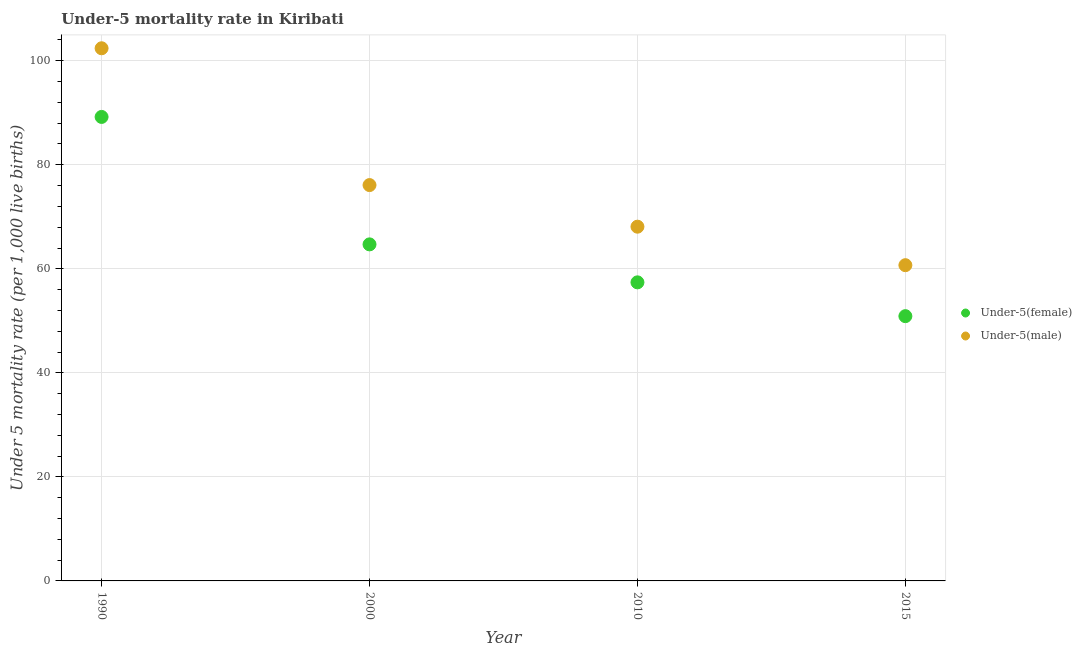What is the under-5 female mortality rate in 2010?
Make the answer very short. 57.4. Across all years, what is the maximum under-5 male mortality rate?
Keep it short and to the point. 102.4. Across all years, what is the minimum under-5 female mortality rate?
Provide a short and direct response. 50.9. In which year was the under-5 female mortality rate minimum?
Offer a very short reply. 2015. What is the total under-5 female mortality rate in the graph?
Provide a short and direct response. 262.2. What is the difference between the under-5 female mortality rate in 2000 and that in 2010?
Give a very brief answer. 7.3. What is the difference between the under-5 male mortality rate in 2010 and the under-5 female mortality rate in 2015?
Your answer should be very brief. 17.2. What is the average under-5 female mortality rate per year?
Ensure brevity in your answer.  65.55. In the year 2015, what is the difference between the under-5 female mortality rate and under-5 male mortality rate?
Your answer should be compact. -9.8. What is the ratio of the under-5 male mortality rate in 1990 to that in 2010?
Keep it short and to the point. 1.5. Is the under-5 female mortality rate in 2000 less than that in 2015?
Ensure brevity in your answer.  No. Is the difference between the under-5 female mortality rate in 2000 and 2010 greater than the difference between the under-5 male mortality rate in 2000 and 2010?
Your response must be concise. No. What is the difference between the highest and the second highest under-5 female mortality rate?
Ensure brevity in your answer.  24.5. What is the difference between the highest and the lowest under-5 male mortality rate?
Make the answer very short. 41.7. Is the sum of the under-5 female mortality rate in 2000 and 2010 greater than the maximum under-5 male mortality rate across all years?
Offer a terse response. Yes. Does the under-5 female mortality rate monotonically increase over the years?
Provide a succinct answer. No. Is the under-5 male mortality rate strictly less than the under-5 female mortality rate over the years?
Provide a succinct answer. No. How many years are there in the graph?
Make the answer very short. 4. Are the values on the major ticks of Y-axis written in scientific E-notation?
Offer a very short reply. No. Does the graph contain grids?
Your response must be concise. Yes. Where does the legend appear in the graph?
Provide a succinct answer. Center right. What is the title of the graph?
Your response must be concise. Under-5 mortality rate in Kiribati. What is the label or title of the Y-axis?
Make the answer very short. Under 5 mortality rate (per 1,0 live births). What is the Under 5 mortality rate (per 1,000 live births) of Under-5(female) in 1990?
Your answer should be compact. 89.2. What is the Under 5 mortality rate (per 1,000 live births) of Under-5(male) in 1990?
Your answer should be very brief. 102.4. What is the Under 5 mortality rate (per 1,000 live births) in Under-5(female) in 2000?
Ensure brevity in your answer.  64.7. What is the Under 5 mortality rate (per 1,000 live births) in Under-5(male) in 2000?
Make the answer very short. 76.1. What is the Under 5 mortality rate (per 1,000 live births) in Under-5(female) in 2010?
Your answer should be compact. 57.4. What is the Under 5 mortality rate (per 1,000 live births) in Under-5(male) in 2010?
Give a very brief answer. 68.1. What is the Under 5 mortality rate (per 1,000 live births) in Under-5(female) in 2015?
Your answer should be compact. 50.9. What is the Under 5 mortality rate (per 1,000 live births) of Under-5(male) in 2015?
Provide a short and direct response. 60.7. Across all years, what is the maximum Under 5 mortality rate (per 1,000 live births) of Under-5(female)?
Provide a short and direct response. 89.2. Across all years, what is the maximum Under 5 mortality rate (per 1,000 live births) of Under-5(male)?
Provide a short and direct response. 102.4. Across all years, what is the minimum Under 5 mortality rate (per 1,000 live births) of Under-5(female)?
Make the answer very short. 50.9. Across all years, what is the minimum Under 5 mortality rate (per 1,000 live births) in Under-5(male)?
Offer a terse response. 60.7. What is the total Under 5 mortality rate (per 1,000 live births) in Under-5(female) in the graph?
Ensure brevity in your answer.  262.2. What is the total Under 5 mortality rate (per 1,000 live births) in Under-5(male) in the graph?
Your answer should be compact. 307.3. What is the difference between the Under 5 mortality rate (per 1,000 live births) in Under-5(female) in 1990 and that in 2000?
Your response must be concise. 24.5. What is the difference between the Under 5 mortality rate (per 1,000 live births) in Under-5(male) in 1990 and that in 2000?
Provide a short and direct response. 26.3. What is the difference between the Under 5 mortality rate (per 1,000 live births) of Under-5(female) in 1990 and that in 2010?
Give a very brief answer. 31.8. What is the difference between the Under 5 mortality rate (per 1,000 live births) in Under-5(male) in 1990 and that in 2010?
Give a very brief answer. 34.3. What is the difference between the Under 5 mortality rate (per 1,000 live births) in Under-5(female) in 1990 and that in 2015?
Keep it short and to the point. 38.3. What is the difference between the Under 5 mortality rate (per 1,000 live births) in Under-5(male) in 1990 and that in 2015?
Offer a terse response. 41.7. What is the difference between the Under 5 mortality rate (per 1,000 live births) in Under-5(female) in 2000 and that in 2010?
Give a very brief answer. 7.3. What is the difference between the Under 5 mortality rate (per 1,000 live births) in Under-5(male) in 2000 and that in 2010?
Provide a succinct answer. 8. What is the difference between the Under 5 mortality rate (per 1,000 live births) in Under-5(female) in 2000 and that in 2015?
Your response must be concise. 13.8. What is the difference between the Under 5 mortality rate (per 1,000 live births) of Under-5(female) in 2010 and that in 2015?
Your answer should be compact. 6.5. What is the difference between the Under 5 mortality rate (per 1,000 live births) of Under-5(male) in 2010 and that in 2015?
Your response must be concise. 7.4. What is the difference between the Under 5 mortality rate (per 1,000 live births) of Under-5(female) in 1990 and the Under 5 mortality rate (per 1,000 live births) of Under-5(male) in 2000?
Ensure brevity in your answer.  13.1. What is the difference between the Under 5 mortality rate (per 1,000 live births) in Under-5(female) in 1990 and the Under 5 mortality rate (per 1,000 live births) in Under-5(male) in 2010?
Make the answer very short. 21.1. What is the difference between the Under 5 mortality rate (per 1,000 live births) of Under-5(female) in 1990 and the Under 5 mortality rate (per 1,000 live births) of Under-5(male) in 2015?
Provide a short and direct response. 28.5. What is the difference between the Under 5 mortality rate (per 1,000 live births) of Under-5(female) in 2000 and the Under 5 mortality rate (per 1,000 live births) of Under-5(male) in 2015?
Your answer should be compact. 4. What is the difference between the Under 5 mortality rate (per 1,000 live births) in Under-5(female) in 2010 and the Under 5 mortality rate (per 1,000 live births) in Under-5(male) in 2015?
Offer a very short reply. -3.3. What is the average Under 5 mortality rate (per 1,000 live births) of Under-5(female) per year?
Provide a succinct answer. 65.55. What is the average Under 5 mortality rate (per 1,000 live births) in Under-5(male) per year?
Offer a terse response. 76.83. In the year 2010, what is the difference between the Under 5 mortality rate (per 1,000 live births) in Under-5(female) and Under 5 mortality rate (per 1,000 live births) in Under-5(male)?
Your response must be concise. -10.7. What is the ratio of the Under 5 mortality rate (per 1,000 live births) of Under-5(female) in 1990 to that in 2000?
Give a very brief answer. 1.38. What is the ratio of the Under 5 mortality rate (per 1,000 live births) of Under-5(male) in 1990 to that in 2000?
Offer a very short reply. 1.35. What is the ratio of the Under 5 mortality rate (per 1,000 live births) of Under-5(female) in 1990 to that in 2010?
Make the answer very short. 1.55. What is the ratio of the Under 5 mortality rate (per 1,000 live births) in Under-5(male) in 1990 to that in 2010?
Provide a succinct answer. 1.5. What is the ratio of the Under 5 mortality rate (per 1,000 live births) of Under-5(female) in 1990 to that in 2015?
Give a very brief answer. 1.75. What is the ratio of the Under 5 mortality rate (per 1,000 live births) of Under-5(male) in 1990 to that in 2015?
Your answer should be very brief. 1.69. What is the ratio of the Under 5 mortality rate (per 1,000 live births) of Under-5(female) in 2000 to that in 2010?
Keep it short and to the point. 1.13. What is the ratio of the Under 5 mortality rate (per 1,000 live births) of Under-5(male) in 2000 to that in 2010?
Make the answer very short. 1.12. What is the ratio of the Under 5 mortality rate (per 1,000 live births) of Under-5(female) in 2000 to that in 2015?
Your answer should be very brief. 1.27. What is the ratio of the Under 5 mortality rate (per 1,000 live births) in Under-5(male) in 2000 to that in 2015?
Offer a very short reply. 1.25. What is the ratio of the Under 5 mortality rate (per 1,000 live births) of Under-5(female) in 2010 to that in 2015?
Your answer should be very brief. 1.13. What is the ratio of the Under 5 mortality rate (per 1,000 live births) in Under-5(male) in 2010 to that in 2015?
Your answer should be very brief. 1.12. What is the difference between the highest and the second highest Under 5 mortality rate (per 1,000 live births) in Under-5(male)?
Keep it short and to the point. 26.3. What is the difference between the highest and the lowest Under 5 mortality rate (per 1,000 live births) in Under-5(female)?
Your response must be concise. 38.3. What is the difference between the highest and the lowest Under 5 mortality rate (per 1,000 live births) of Under-5(male)?
Keep it short and to the point. 41.7. 